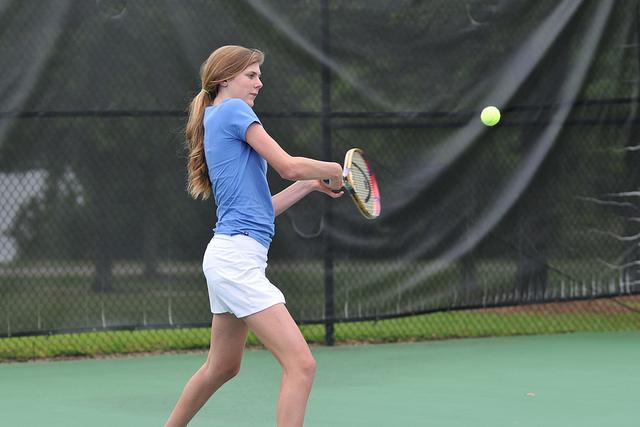How many tennis balls are there?
Give a very brief answer. 1. What is she about to hit with the racket?
Give a very brief answer. Ball. Did the girl hit the ball?
Short answer required. Yes. Is this woman a professional?
Write a very short answer. No. Is the woman attempting to hit a little bomb?
Answer briefly. No. 